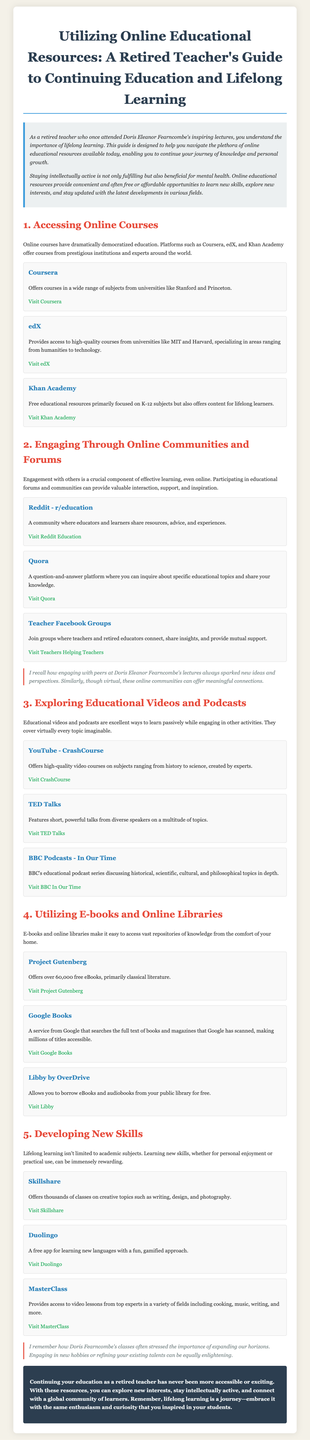What are some online course platforms mentioned? The document lists Coursera, edX, and Khan Academy as platforms offering online courses.
Answer: Coursera, edX, Khan Academy What topic does the Reddit community r/education focus on? The community r/education is where educators and learners share resources, advice, and experiences.
Answer: Education How many free eBooks does Project Gutenberg offer? The document states that Project Gutenberg offers over 60,000 free eBooks.
Answer: Over 60,000 Which online resource is recommended for learning new languages? The document suggests Duolingo as a free app for learning new languages.
Answer: Duolingo What is the main benefit of engaging in online communities according to the guide? The document emphasizes that engagement with others provides valuable interaction, support, and inspiration.
Answer: Valuable interaction, support, and inspiration What type of content does TED Talks feature? The document describes TED Talks as featuring short, powerful talks from diverse speakers on a multitude of topics.
Answer: Short, powerful talks What is the purpose of this user guide? The document aims to help retired teachers navigate online educational resources for continuing education and lifelong learning.
Answer: Help retired teachers navigate online educational resources Which resource allows borrowing eBooks from public libraries? The guide mentions Libby by OverDrive as allowing borrowing eBooks and audiobooks from public libraries.
Answer: Libby by OverDrive 